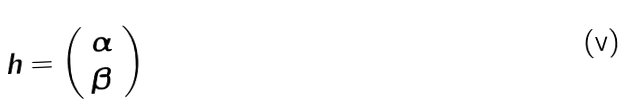Convert formula to latex. <formula><loc_0><loc_0><loc_500><loc_500>h = \left ( \begin{array} { l } \alpha \\ \beta \\ \end{array} \right ) \</formula> 